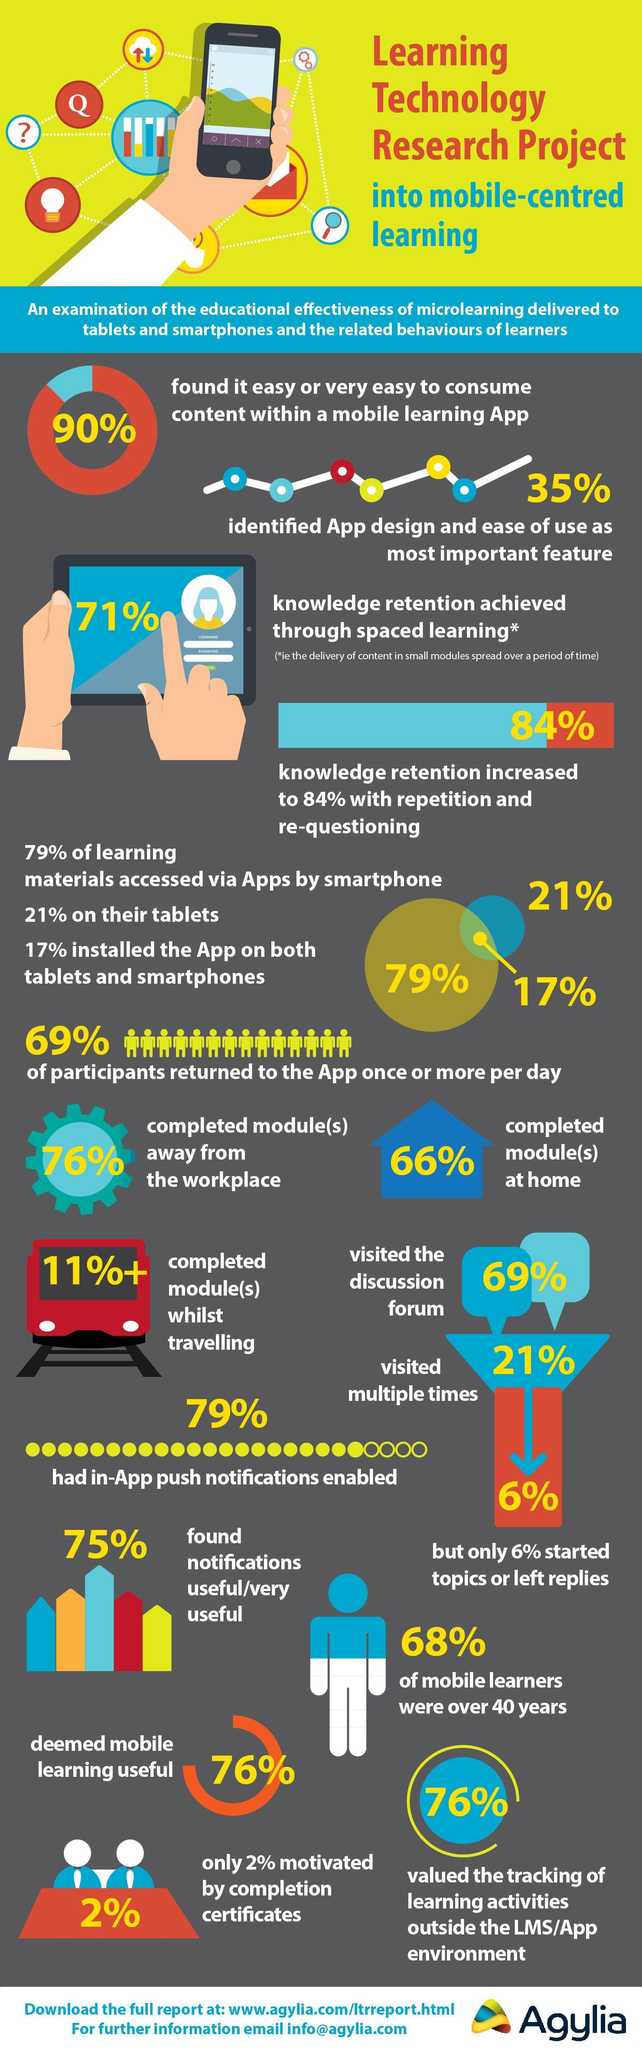What % of people used only apps in smartphones
Answer the question with a short phrase. 62 What % has in-App push notifications enabled 79% What % of people used only apps in tablets 4 how many % did not find it easy or very easy to consume content within a mobile learning App 10 What is the % of knowledge retention achieved through spaced learning 71% What % of mobile learners were 40 or below 32 